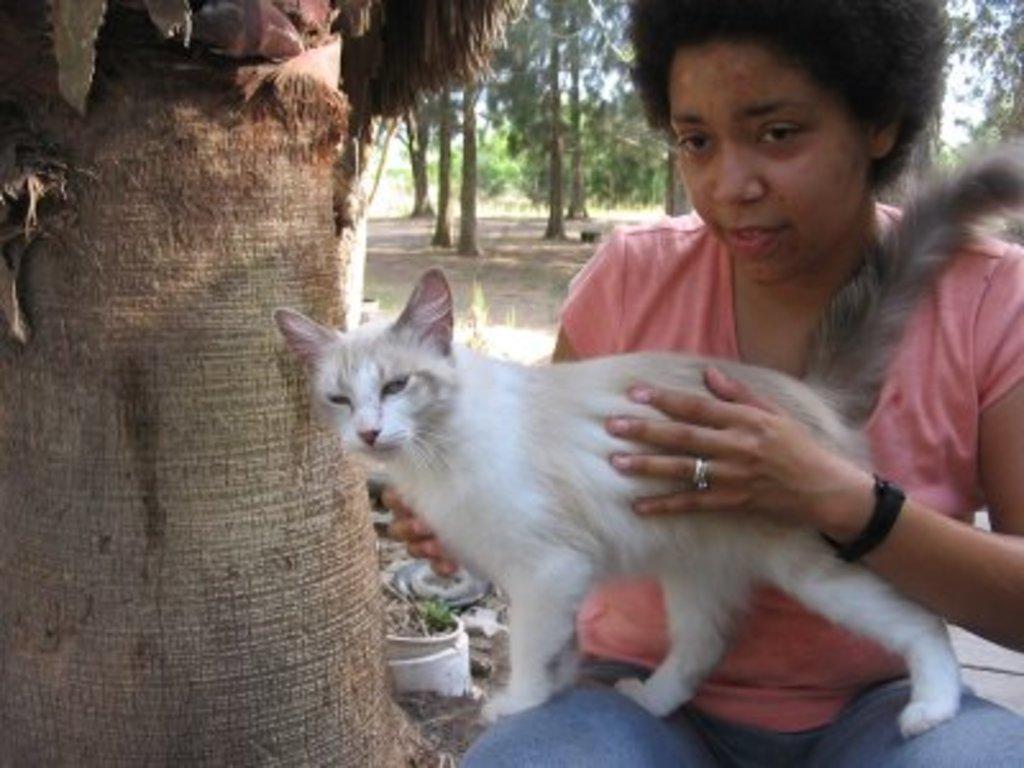How would you summarize this image in a sentence or two? In this image I can see the person holding the cat which is in white color. The person is wearing the orange and blue color dress. To the left I can see the branch of the tree. In the back there are many trees and the sky. 